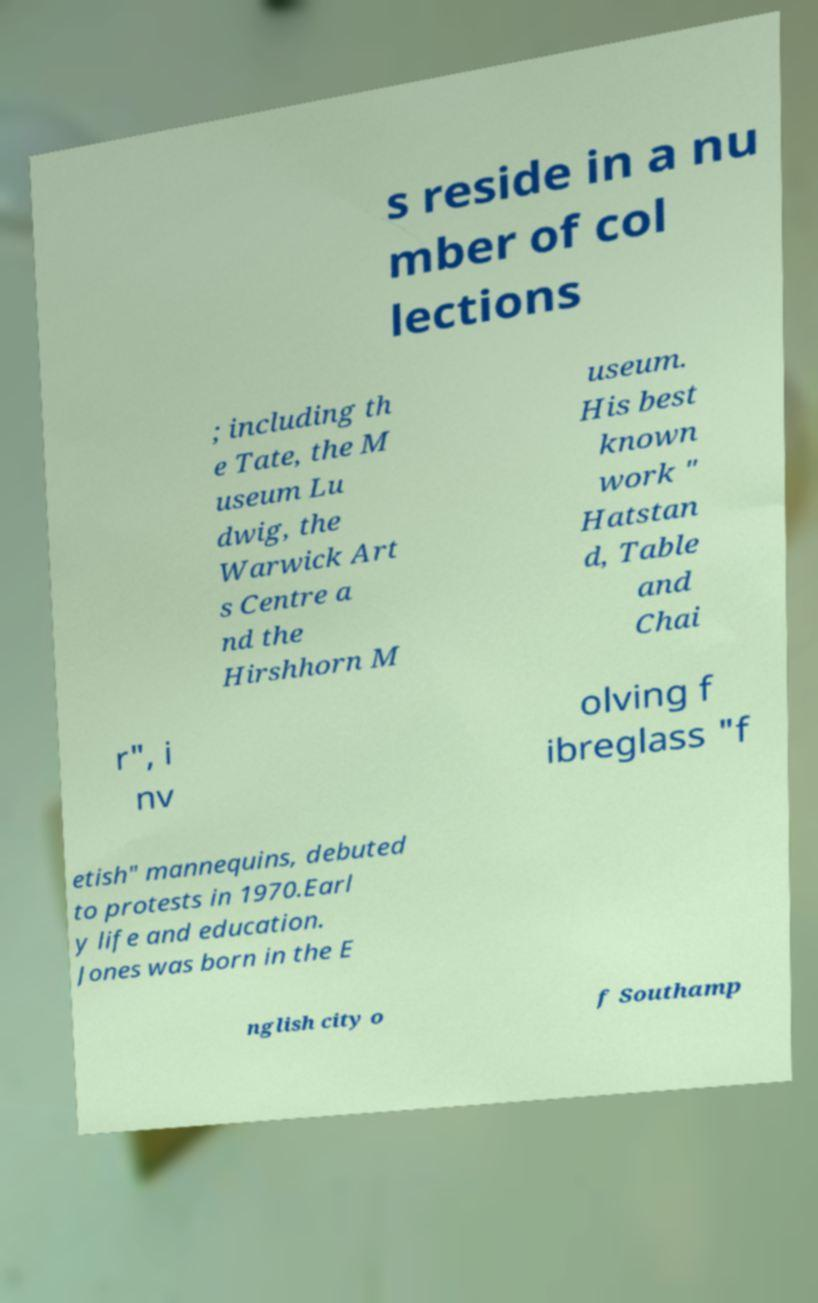I need the written content from this picture converted into text. Can you do that? s reside in a nu mber of col lections ; including th e Tate, the M useum Lu dwig, the Warwick Art s Centre a nd the Hirshhorn M useum. His best known work " Hatstan d, Table and Chai r", i nv olving f ibreglass "f etish" mannequins, debuted to protests in 1970.Earl y life and education. Jones was born in the E nglish city o f Southamp 